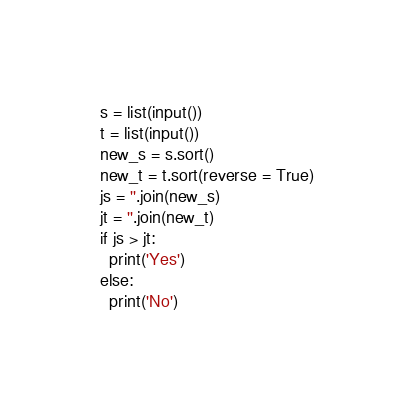<code> <loc_0><loc_0><loc_500><loc_500><_Python_>s = list(input())
t = list(input())
new_s = s.sort()
new_t = t.sort(reverse = True)
js = ''.join(new_s)
jt = ''.join(new_t)
if js > jt:
  print('Yes')
else:
  print('No')</code> 